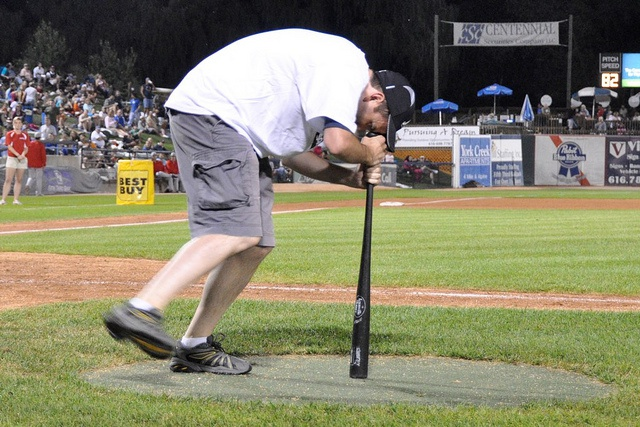Describe the objects in this image and their specific colors. I can see people in black, white, darkgray, and gray tones, people in black, gray, and darkgray tones, baseball bat in black, gray, darkgray, and tan tones, people in black, tan, darkgray, and brown tones, and people in black, brown, gray, and maroon tones in this image. 